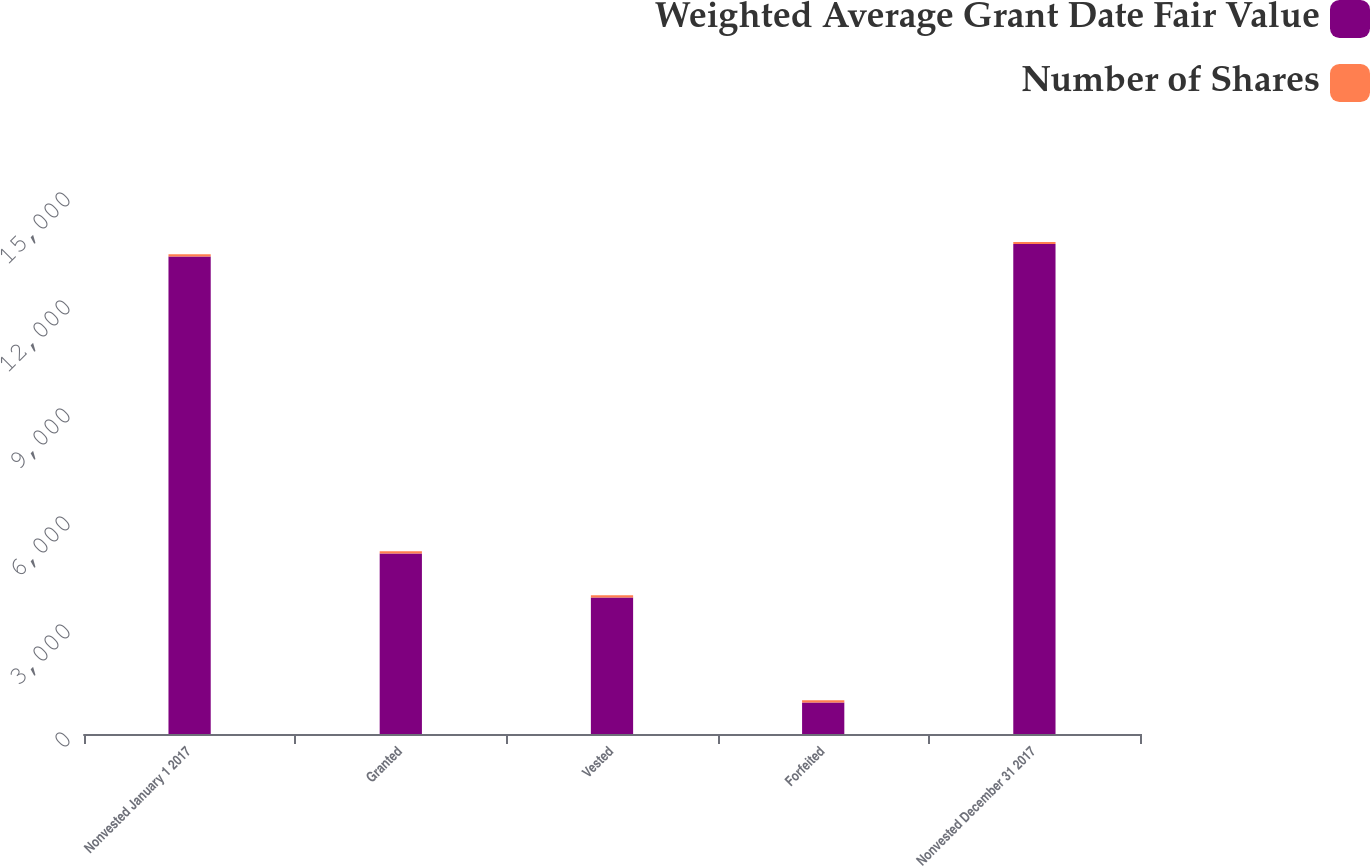Convert chart. <chart><loc_0><loc_0><loc_500><loc_500><stacked_bar_chart><ecel><fcel>Nonvested January 1 2017<fcel>Granted<fcel>Vested<fcel>Forfeited<fcel>Nonvested December 31 2017<nl><fcel>Weighted Average Grant Date Fair Value<fcel>13266<fcel>5014<fcel>3795<fcel>876<fcel>13609<nl><fcel>Number of Shares<fcel>57.19<fcel>63.85<fcel>58.13<fcel>58.22<fcel>59.32<nl></chart> 